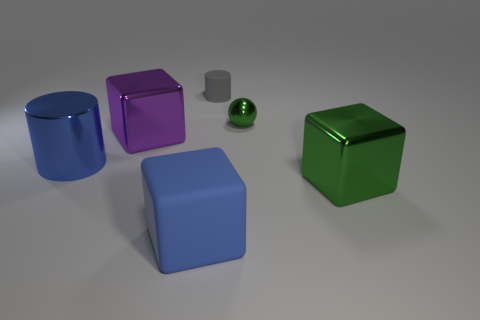What number of things are either cubes to the left of the gray rubber cylinder or metal objects behind the green metal block? There are two cubes to the left of the gray rubber cylinder and one metal sphere behind the green metal cube. Therefore, the total number of such objects is three. 